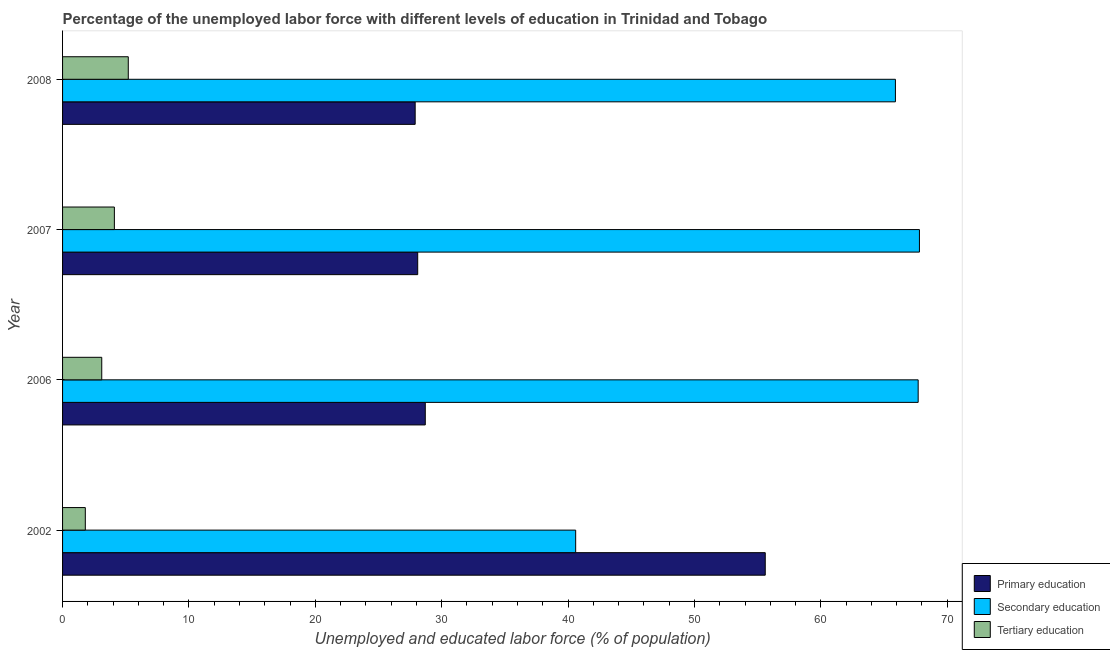How many different coloured bars are there?
Make the answer very short. 3. Are the number of bars on each tick of the Y-axis equal?
Your answer should be compact. Yes. How many bars are there on the 1st tick from the top?
Give a very brief answer. 3. How many bars are there on the 4th tick from the bottom?
Provide a succinct answer. 3. What is the percentage of labor force who received tertiary education in 2002?
Your answer should be compact. 1.8. Across all years, what is the maximum percentage of labor force who received tertiary education?
Offer a terse response. 5.2. Across all years, what is the minimum percentage of labor force who received primary education?
Offer a very short reply. 27.9. In which year was the percentage of labor force who received tertiary education minimum?
Ensure brevity in your answer.  2002. What is the total percentage of labor force who received primary education in the graph?
Give a very brief answer. 140.3. What is the difference between the percentage of labor force who received secondary education in 2007 and that in 2008?
Offer a very short reply. 1.9. What is the difference between the percentage of labor force who received primary education in 2006 and the percentage of labor force who received secondary education in 2008?
Ensure brevity in your answer.  -37.2. What is the average percentage of labor force who received primary education per year?
Provide a short and direct response. 35.08. In how many years, is the percentage of labor force who received primary education greater than 12 %?
Offer a terse response. 4. What is the ratio of the percentage of labor force who received tertiary education in 2006 to that in 2008?
Your response must be concise. 0.6. Is the percentage of labor force who received primary education in 2002 less than that in 2006?
Your answer should be very brief. No. Is the difference between the percentage of labor force who received primary education in 2002 and 2006 greater than the difference between the percentage of labor force who received tertiary education in 2002 and 2006?
Offer a terse response. Yes. What is the difference between the highest and the second highest percentage of labor force who received primary education?
Give a very brief answer. 26.9. What is the difference between the highest and the lowest percentage of labor force who received primary education?
Ensure brevity in your answer.  27.7. In how many years, is the percentage of labor force who received secondary education greater than the average percentage of labor force who received secondary education taken over all years?
Keep it short and to the point. 3. What does the 1st bar from the top in 2006 represents?
Your answer should be very brief. Tertiary education. What does the 2nd bar from the bottom in 2002 represents?
Give a very brief answer. Secondary education. Is it the case that in every year, the sum of the percentage of labor force who received primary education and percentage of labor force who received secondary education is greater than the percentage of labor force who received tertiary education?
Make the answer very short. Yes. How many bars are there?
Provide a succinct answer. 12. Are the values on the major ticks of X-axis written in scientific E-notation?
Your answer should be compact. No. Does the graph contain grids?
Ensure brevity in your answer.  No. Where does the legend appear in the graph?
Your answer should be compact. Bottom right. What is the title of the graph?
Make the answer very short. Percentage of the unemployed labor force with different levels of education in Trinidad and Tobago. Does "Transport services" appear as one of the legend labels in the graph?
Offer a terse response. No. What is the label or title of the X-axis?
Give a very brief answer. Unemployed and educated labor force (% of population). What is the Unemployed and educated labor force (% of population) in Primary education in 2002?
Your response must be concise. 55.6. What is the Unemployed and educated labor force (% of population) of Secondary education in 2002?
Make the answer very short. 40.6. What is the Unemployed and educated labor force (% of population) of Tertiary education in 2002?
Offer a terse response. 1.8. What is the Unemployed and educated labor force (% of population) in Primary education in 2006?
Make the answer very short. 28.7. What is the Unemployed and educated labor force (% of population) of Secondary education in 2006?
Provide a succinct answer. 67.7. What is the Unemployed and educated labor force (% of population) in Tertiary education in 2006?
Provide a succinct answer. 3.1. What is the Unemployed and educated labor force (% of population) in Primary education in 2007?
Your answer should be compact. 28.1. What is the Unemployed and educated labor force (% of population) in Secondary education in 2007?
Keep it short and to the point. 67.8. What is the Unemployed and educated labor force (% of population) of Tertiary education in 2007?
Provide a short and direct response. 4.1. What is the Unemployed and educated labor force (% of population) of Primary education in 2008?
Offer a very short reply. 27.9. What is the Unemployed and educated labor force (% of population) in Secondary education in 2008?
Provide a short and direct response. 65.9. What is the Unemployed and educated labor force (% of population) in Tertiary education in 2008?
Your answer should be very brief. 5.2. Across all years, what is the maximum Unemployed and educated labor force (% of population) in Primary education?
Offer a very short reply. 55.6. Across all years, what is the maximum Unemployed and educated labor force (% of population) in Secondary education?
Provide a short and direct response. 67.8. Across all years, what is the maximum Unemployed and educated labor force (% of population) in Tertiary education?
Your answer should be compact. 5.2. Across all years, what is the minimum Unemployed and educated labor force (% of population) of Primary education?
Offer a very short reply. 27.9. Across all years, what is the minimum Unemployed and educated labor force (% of population) in Secondary education?
Offer a very short reply. 40.6. Across all years, what is the minimum Unemployed and educated labor force (% of population) in Tertiary education?
Offer a very short reply. 1.8. What is the total Unemployed and educated labor force (% of population) of Primary education in the graph?
Keep it short and to the point. 140.3. What is the total Unemployed and educated labor force (% of population) in Secondary education in the graph?
Your answer should be compact. 242. What is the difference between the Unemployed and educated labor force (% of population) in Primary education in 2002 and that in 2006?
Ensure brevity in your answer.  26.9. What is the difference between the Unemployed and educated labor force (% of population) in Secondary education in 2002 and that in 2006?
Keep it short and to the point. -27.1. What is the difference between the Unemployed and educated labor force (% of population) in Secondary education in 2002 and that in 2007?
Offer a terse response. -27.2. What is the difference between the Unemployed and educated labor force (% of population) in Tertiary education in 2002 and that in 2007?
Keep it short and to the point. -2.3. What is the difference between the Unemployed and educated labor force (% of population) of Primary education in 2002 and that in 2008?
Your answer should be very brief. 27.7. What is the difference between the Unemployed and educated labor force (% of population) of Secondary education in 2002 and that in 2008?
Ensure brevity in your answer.  -25.3. What is the difference between the Unemployed and educated labor force (% of population) of Tertiary education in 2002 and that in 2008?
Provide a succinct answer. -3.4. What is the difference between the Unemployed and educated labor force (% of population) in Secondary education in 2006 and that in 2007?
Provide a short and direct response. -0.1. What is the difference between the Unemployed and educated labor force (% of population) in Primary education in 2006 and that in 2008?
Your answer should be very brief. 0.8. What is the difference between the Unemployed and educated labor force (% of population) of Tertiary education in 2006 and that in 2008?
Ensure brevity in your answer.  -2.1. What is the difference between the Unemployed and educated labor force (% of population) in Secondary education in 2007 and that in 2008?
Your response must be concise. 1.9. What is the difference between the Unemployed and educated labor force (% of population) of Primary education in 2002 and the Unemployed and educated labor force (% of population) of Tertiary education in 2006?
Keep it short and to the point. 52.5. What is the difference between the Unemployed and educated labor force (% of population) in Secondary education in 2002 and the Unemployed and educated labor force (% of population) in Tertiary education in 2006?
Offer a very short reply. 37.5. What is the difference between the Unemployed and educated labor force (% of population) of Primary education in 2002 and the Unemployed and educated labor force (% of population) of Secondary education in 2007?
Offer a terse response. -12.2. What is the difference between the Unemployed and educated labor force (% of population) of Primary education in 2002 and the Unemployed and educated labor force (% of population) of Tertiary education in 2007?
Provide a succinct answer. 51.5. What is the difference between the Unemployed and educated labor force (% of population) in Secondary education in 2002 and the Unemployed and educated labor force (% of population) in Tertiary education in 2007?
Your answer should be very brief. 36.5. What is the difference between the Unemployed and educated labor force (% of population) of Primary education in 2002 and the Unemployed and educated labor force (% of population) of Tertiary education in 2008?
Offer a terse response. 50.4. What is the difference between the Unemployed and educated labor force (% of population) of Secondary education in 2002 and the Unemployed and educated labor force (% of population) of Tertiary education in 2008?
Your answer should be very brief. 35.4. What is the difference between the Unemployed and educated labor force (% of population) of Primary education in 2006 and the Unemployed and educated labor force (% of population) of Secondary education in 2007?
Provide a succinct answer. -39.1. What is the difference between the Unemployed and educated labor force (% of population) in Primary education in 2006 and the Unemployed and educated labor force (% of population) in Tertiary education in 2007?
Keep it short and to the point. 24.6. What is the difference between the Unemployed and educated labor force (% of population) of Secondary education in 2006 and the Unemployed and educated labor force (% of population) of Tertiary education in 2007?
Your response must be concise. 63.6. What is the difference between the Unemployed and educated labor force (% of population) in Primary education in 2006 and the Unemployed and educated labor force (% of population) in Secondary education in 2008?
Your response must be concise. -37.2. What is the difference between the Unemployed and educated labor force (% of population) of Secondary education in 2006 and the Unemployed and educated labor force (% of population) of Tertiary education in 2008?
Ensure brevity in your answer.  62.5. What is the difference between the Unemployed and educated labor force (% of population) of Primary education in 2007 and the Unemployed and educated labor force (% of population) of Secondary education in 2008?
Your response must be concise. -37.8. What is the difference between the Unemployed and educated labor force (% of population) of Primary education in 2007 and the Unemployed and educated labor force (% of population) of Tertiary education in 2008?
Your answer should be very brief. 22.9. What is the difference between the Unemployed and educated labor force (% of population) of Secondary education in 2007 and the Unemployed and educated labor force (% of population) of Tertiary education in 2008?
Give a very brief answer. 62.6. What is the average Unemployed and educated labor force (% of population) in Primary education per year?
Make the answer very short. 35.08. What is the average Unemployed and educated labor force (% of population) of Secondary education per year?
Offer a very short reply. 60.5. What is the average Unemployed and educated labor force (% of population) in Tertiary education per year?
Ensure brevity in your answer.  3.55. In the year 2002, what is the difference between the Unemployed and educated labor force (% of population) in Primary education and Unemployed and educated labor force (% of population) in Tertiary education?
Provide a short and direct response. 53.8. In the year 2002, what is the difference between the Unemployed and educated labor force (% of population) of Secondary education and Unemployed and educated labor force (% of population) of Tertiary education?
Give a very brief answer. 38.8. In the year 2006, what is the difference between the Unemployed and educated labor force (% of population) of Primary education and Unemployed and educated labor force (% of population) of Secondary education?
Ensure brevity in your answer.  -39. In the year 2006, what is the difference between the Unemployed and educated labor force (% of population) of Primary education and Unemployed and educated labor force (% of population) of Tertiary education?
Your response must be concise. 25.6. In the year 2006, what is the difference between the Unemployed and educated labor force (% of population) in Secondary education and Unemployed and educated labor force (% of population) in Tertiary education?
Keep it short and to the point. 64.6. In the year 2007, what is the difference between the Unemployed and educated labor force (% of population) in Primary education and Unemployed and educated labor force (% of population) in Secondary education?
Offer a terse response. -39.7. In the year 2007, what is the difference between the Unemployed and educated labor force (% of population) of Primary education and Unemployed and educated labor force (% of population) of Tertiary education?
Offer a terse response. 24. In the year 2007, what is the difference between the Unemployed and educated labor force (% of population) of Secondary education and Unemployed and educated labor force (% of population) of Tertiary education?
Keep it short and to the point. 63.7. In the year 2008, what is the difference between the Unemployed and educated labor force (% of population) in Primary education and Unemployed and educated labor force (% of population) in Secondary education?
Your answer should be compact. -38. In the year 2008, what is the difference between the Unemployed and educated labor force (% of population) of Primary education and Unemployed and educated labor force (% of population) of Tertiary education?
Give a very brief answer. 22.7. In the year 2008, what is the difference between the Unemployed and educated labor force (% of population) in Secondary education and Unemployed and educated labor force (% of population) in Tertiary education?
Keep it short and to the point. 60.7. What is the ratio of the Unemployed and educated labor force (% of population) in Primary education in 2002 to that in 2006?
Your response must be concise. 1.94. What is the ratio of the Unemployed and educated labor force (% of population) of Secondary education in 2002 to that in 2006?
Your answer should be very brief. 0.6. What is the ratio of the Unemployed and educated labor force (% of population) of Tertiary education in 2002 to that in 2006?
Give a very brief answer. 0.58. What is the ratio of the Unemployed and educated labor force (% of population) of Primary education in 2002 to that in 2007?
Ensure brevity in your answer.  1.98. What is the ratio of the Unemployed and educated labor force (% of population) in Secondary education in 2002 to that in 2007?
Provide a short and direct response. 0.6. What is the ratio of the Unemployed and educated labor force (% of population) of Tertiary education in 2002 to that in 2007?
Give a very brief answer. 0.44. What is the ratio of the Unemployed and educated labor force (% of population) in Primary education in 2002 to that in 2008?
Provide a short and direct response. 1.99. What is the ratio of the Unemployed and educated labor force (% of population) in Secondary education in 2002 to that in 2008?
Offer a very short reply. 0.62. What is the ratio of the Unemployed and educated labor force (% of population) of Tertiary education in 2002 to that in 2008?
Make the answer very short. 0.35. What is the ratio of the Unemployed and educated labor force (% of population) of Primary education in 2006 to that in 2007?
Keep it short and to the point. 1.02. What is the ratio of the Unemployed and educated labor force (% of population) of Secondary education in 2006 to that in 2007?
Ensure brevity in your answer.  1. What is the ratio of the Unemployed and educated labor force (% of population) of Tertiary education in 2006 to that in 2007?
Offer a terse response. 0.76. What is the ratio of the Unemployed and educated labor force (% of population) of Primary education in 2006 to that in 2008?
Your answer should be very brief. 1.03. What is the ratio of the Unemployed and educated labor force (% of population) in Secondary education in 2006 to that in 2008?
Ensure brevity in your answer.  1.03. What is the ratio of the Unemployed and educated labor force (% of population) in Tertiary education in 2006 to that in 2008?
Keep it short and to the point. 0.6. What is the ratio of the Unemployed and educated labor force (% of population) of Secondary education in 2007 to that in 2008?
Ensure brevity in your answer.  1.03. What is the ratio of the Unemployed and educated labor force (% of population) of Tertiary education in 2007 to that in 2008?
Give a very brief answer. 0.79. What is the difference between the highest and the second highest Unemployed and educated labor force (% of population) of Primary education?
Provide a succinct answer. 26.9. What is the difference between the highest and the lowest Unemployed and educated labor force (% of population) of Primary education?
Provide a succinct answer. 27.7. What is the difference between the highest and the lowest Unemployed and educated labor force (% of population) of Secondary education?
Offer a very short reply. 27.2. 